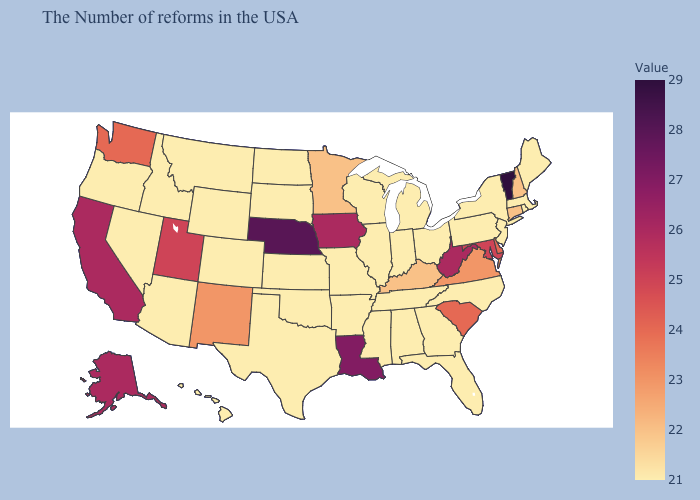Does Iowa have the lowest value in the MidWest?
Short answer required. No. Does Alaska have a higher value than Florida?
Short answer required. Yes. Does Alaska have a higher value than Pennsylvania?
Quick response, please. Yes. Does the map have missing data?
Write a very short answer. No. Does Arizona have the lowest value in the West?
Keep it brief. Yes. Is the legend a continuous bar?
Keep it brief. Yes. 